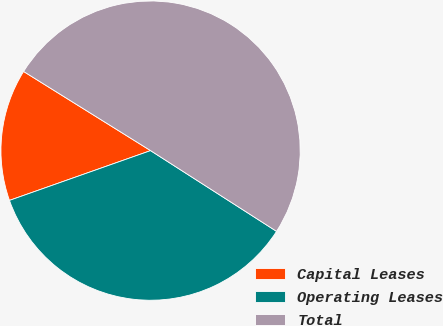Convert chart to OTSL. <chart><loc_0><loc_0><loc_500><loc_500><pie_chart><fcel>Capital Leases<fcel>Operating Leases<fcel>Total<nl><fcel>14.27%<fcel>35.53%<fcel>50.2%<nl></chart> 